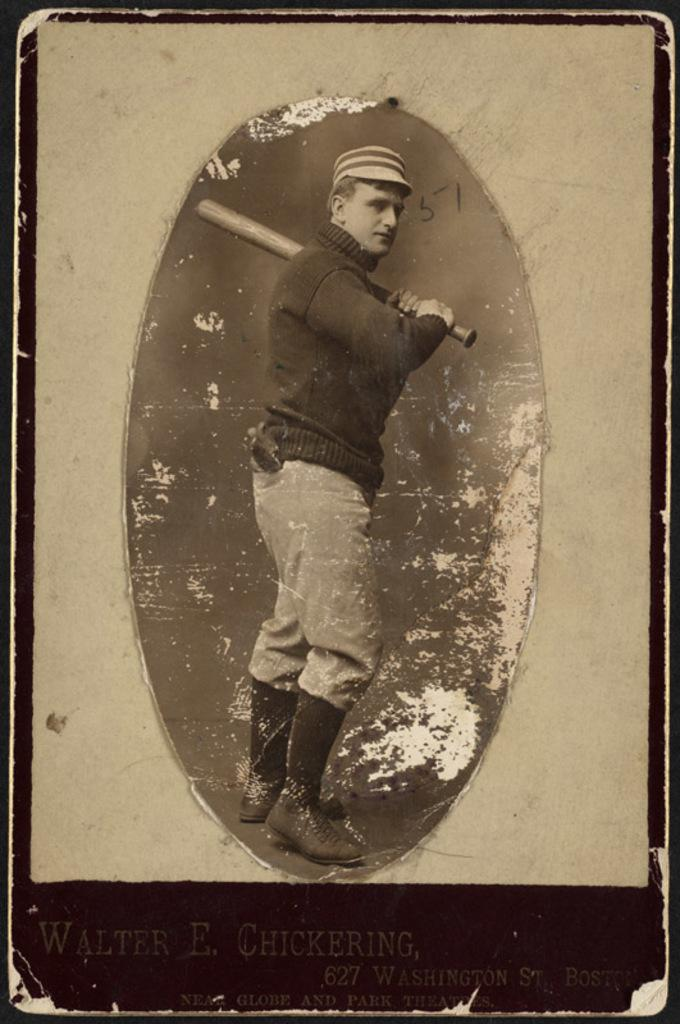What is shown on the paper in the image? There is a person depicted on paper. What else can be seen on the paper besides the person? There is writing on the paper. What object is the person holding in the image? The person is holding a baseball bat. Where is the sink located in the image? There is no sink present in the image. How many sheep are visible in the image? There are no sheep present in the image. 